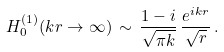<formula> <loc_0><loc_0><loc_500><loc_500>H _ { 0 } ^ { ( 1 ) } ( k r \to \infty ) \, \sim \, \frac { 1 - i } { \sqrt { \pi k } } \, \frac { e ^ { i k r } } { \sqrt { r } } \, .</formula> 